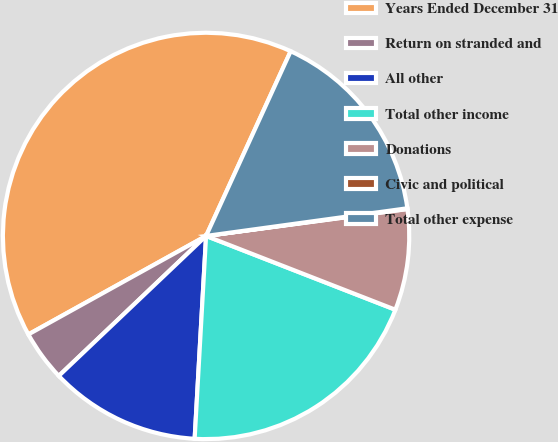<chart> <loc_0><loc_0><loc_500><loc_500><pie_chart><fcel>Years Ended December 31<fcel>Return on stranded and<fcel>All other<fcel>Total other income<fcel>Donations<fcel>Civic and political<fcel>Total other expense<nl><fcel>39.89%<fcel>4.04%<fcel>12.01%<fcel>19.98%<fcel>8.03%<fcel>0.06%<fcel>15.99%<nl></chart> 